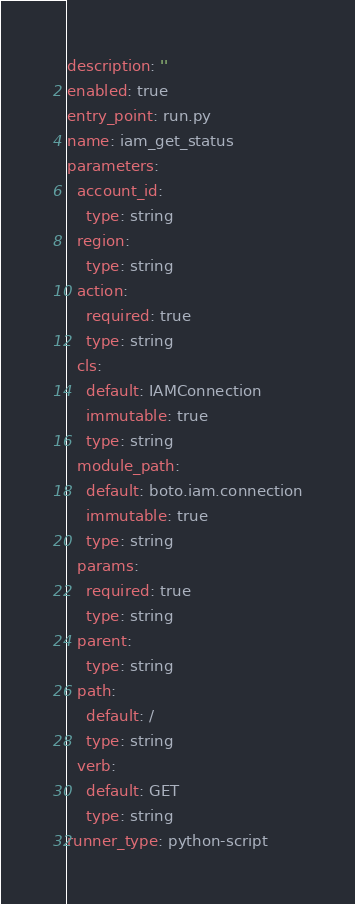Convert code to text. <code><loc_0><loc_0><loc_500><loc_500><_YAML_>description: ''
enabled: true
entry_point: run.py
name: iam_get_status
parameters:
  account_id:
    type: string
  region:
    type: string
  action:
    required: true
    type: string
  cls:
    default: IAMConnection
    immutable: true
    type: string
  module_path:
    default: boto.iam.connection
    immutable: true
    type: string
  params:
    required: true
    type: string
  parent:
    type: string
  path:
    default: /
    type: string
  verb:
    default: GET
    type: string
runner_type: python-script
</code> 